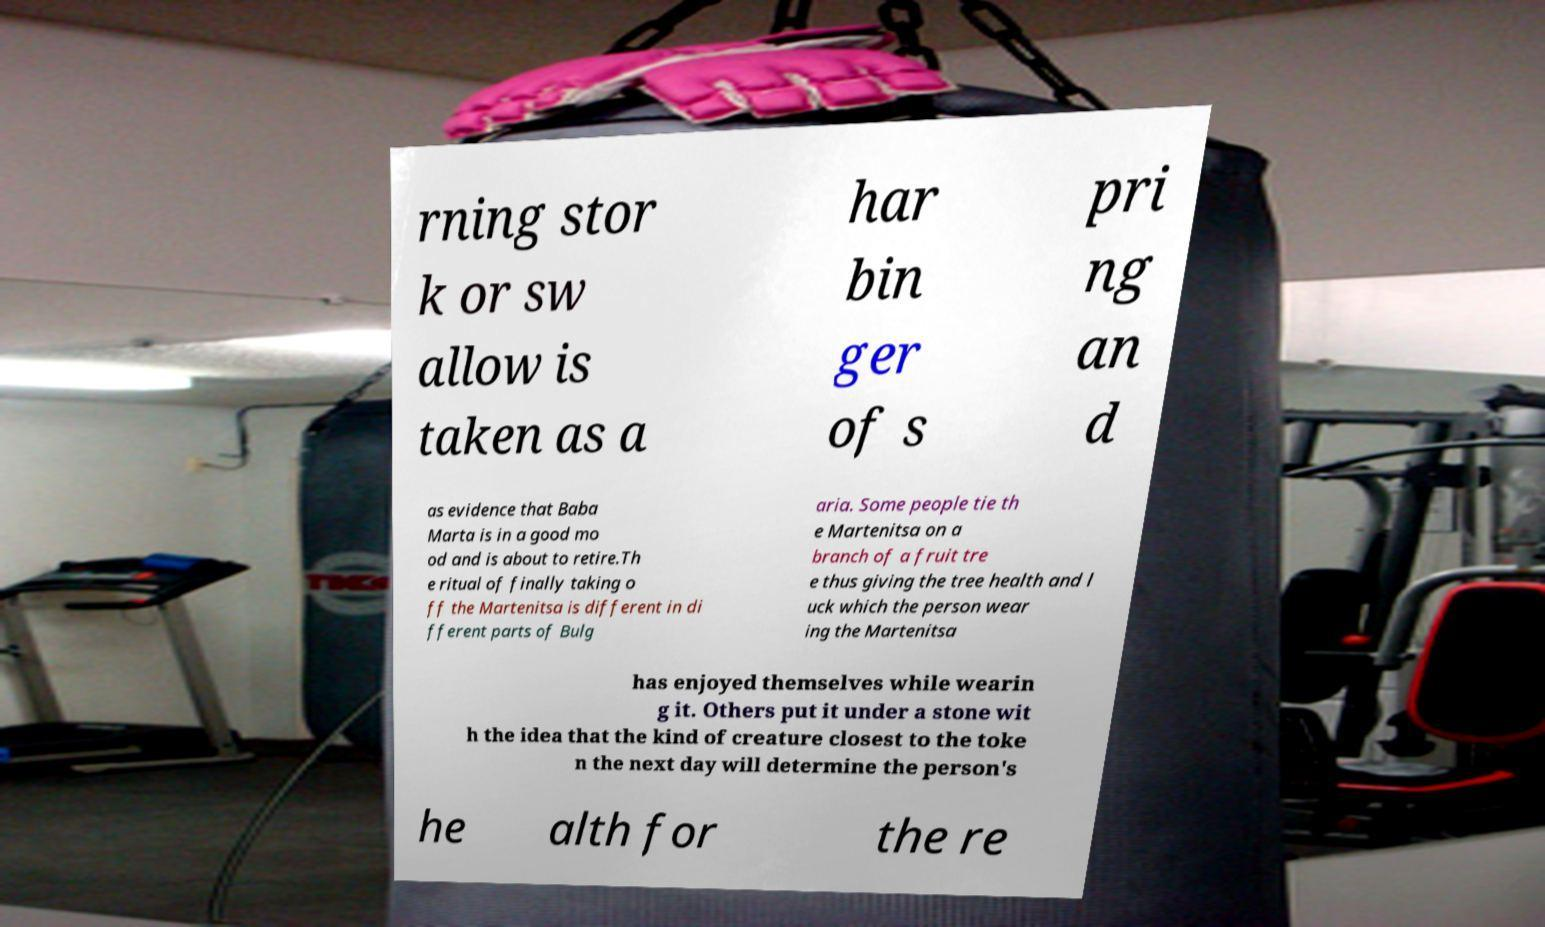I need the written content from this picture converted into text. Can you do that? rning stor k or sw allow is taken as a har bin ger of s pri ng an d as evidence that Baba Marta is in a good mo od and is about to retire.Th e ritual of finally taking o ff the Martenitsa is different in di fferent parts of Bulg aria. Some people tie th e Martenitsa on a branch of a fruit tre e thus giving the tree health and l uck which the person wear ing the Martenitsa has enjoyed themselves while wearin g it. Others put it under a stone wit h the idea that the kind of creature closest to the toke n the next day will determine the person's he alth for the re 